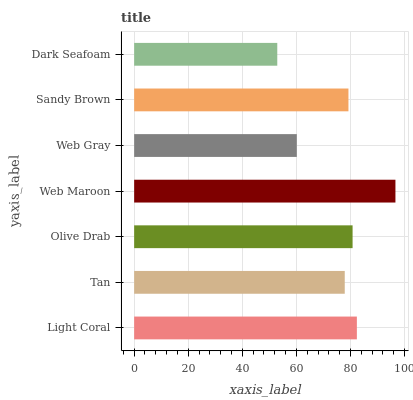Is Dark Seafoam the minimum?
Answer yes or no. Yes. Is Web Maroon the maximum?
Answer yes or no. Yes. Is Tan the minimum?
Answer yes or no. No. Is Tan the maximum?
Answer yes or no. No. Is Light Coral greater than Tan?
Answer yes or no. Yes. Is Tan less than Light Coral?
Answer yes or no. Yes. Is Tan greater than Light Coral?
Answer yes or no. No. Is Light Coral less than Tan?
Answer yes or no. No. Is Sandy Brown the high median?
Answer yes or no. Yes. Is Sandy Brown the low median?
Answer yes or no. Yes. Is Web Gray the high median?
Answer yes or no. No. Is Light Coral the low median?
Answer yes or no. No. 